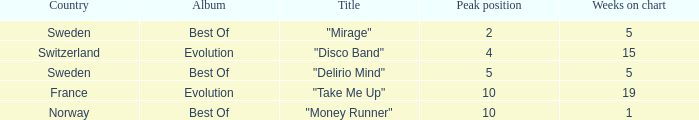What is the weeks on chart for the single from france? 19.0. 